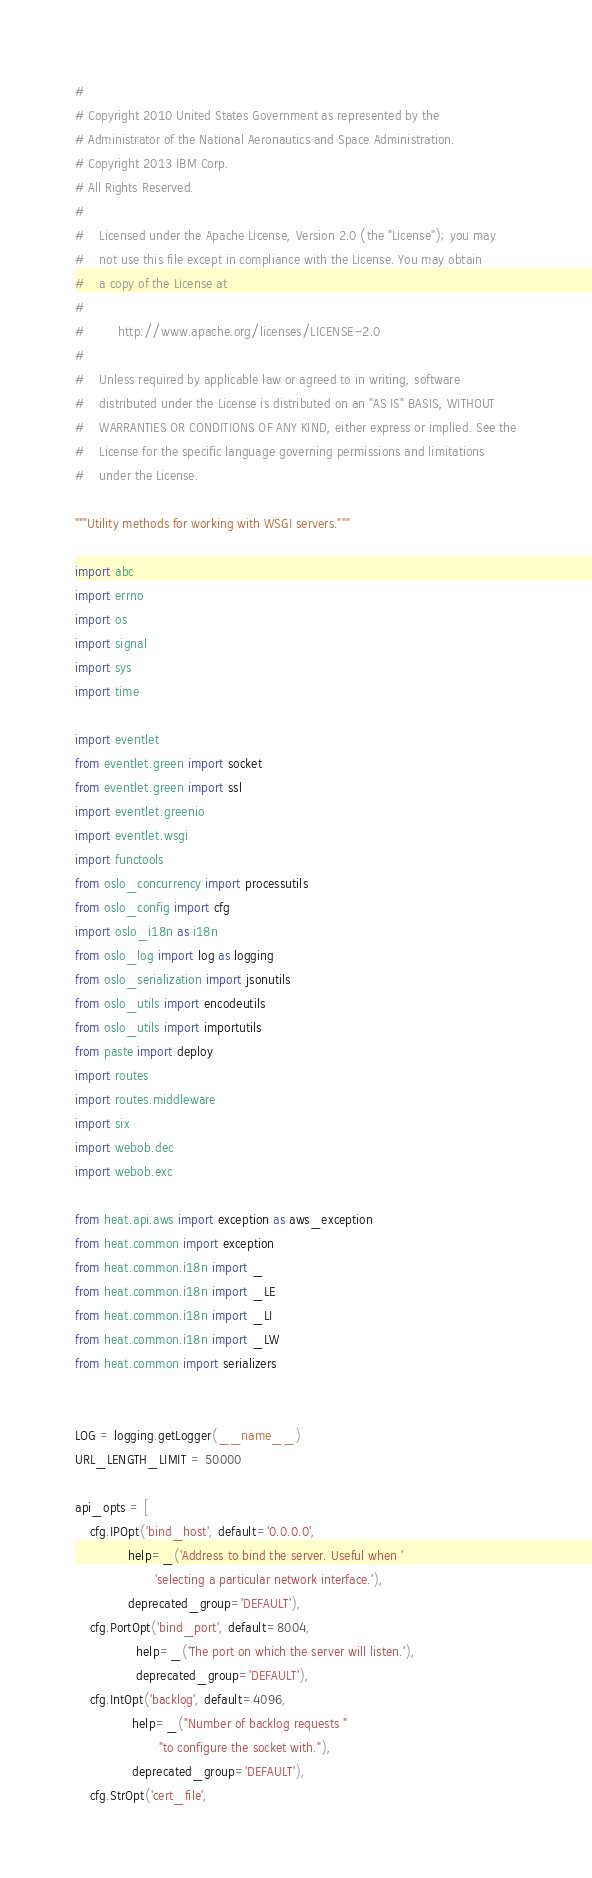<code> <loc_0><loc_0><loc_500><loc_500><_Python_>#
# Copyright 2010 United States Government as represented by the
# Administrator of the National Aeronautics and Space Administration.
# Copyright 2013 IBM Corp.
# All Rights Reserved.
#
#    Licensed under the Apache License, Version 2.0 (the "License"); you may
#    not use this file except in compliance with the License. You may obtain
#    a copy of the License at
#
#         http://www.apache.org/licenses/LICENSE-2.0
#
#    Unless required by applicable law or agreed to in writing, software
#    distributed under the License is distributed on an "AS IS" BASIS, WITHOUT
#    WARRANTIES OR CONDITIONS OF ANY KIND, either express or implied. See the
#    License for the specific language governing permissions and limitations
#    under the License.

"""Utility methods for working with WSGI servers."""

import abc
import errno
import os
import signal
import sys
import time

import eventlet
from eventlet.green import socket
from eventlet.green import ssl
import eventlet.greenio
import eventlet.wsgi
import functools
from oslo_concurrency import processutils
from oslo_config import cfg
import oslo_i18n as i18n
from oslo_log import log as logging
from oslo_serialization import jsonutils
from oslo_utils import encodeutils
from oslo_utils import importutils
from paste import deploy
import routes
import routes.middleware
import six
import webob.dec
import webob.exc

from heat.api.aws import exception as aws_exception
from heat.common import exception
from heat.common.i18n import _
from heat.common.i18n import _LE
from heat.common.i18n import _LI
from heat.common.i18n import _LW
from heat.common import serializers


LOG = logging.getLogger(__name__)
URL_LENGTH_LIMIT = 50000

api_opts = [
    cfg.IPOpt('bind_host', default='0.0.0.0',
              help=_('Address to bind the server. Useful when '
                     'selecting a particular network interface.'),
              deprecated_group='DEFAULT'),
    cfg.PortOpt('bind_port', default=8004,
                help=_('The port on which the server will listen.'),
                deprecated_group='DEFAULT'),
    cfg.IntOpt('backlog', default=4096,
               help=_("Number of backlog requests "
                      "to configure the socket with."),
               deprecated_group='DEFAULT'),
    cfg.StrOpt('cert_file',</code> 